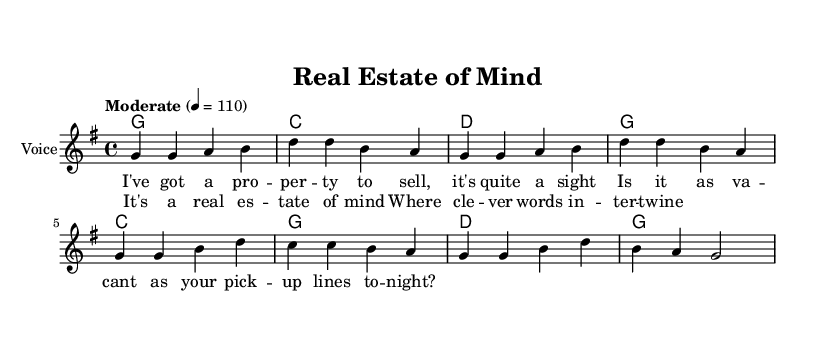What is the key signature of this music? The key signature is G major, which has one sharp (F#). This is determined by looking at the key signature indicated at the beginning of the staff.
Answer: G major What is the time signature of this piece? The time signature is 4/4, which means there are four beats in each measure and the quarter note gets one beat. This is indicated at the beginning of the music sheet.
Answer: 4/4 What is the tempo marking for the piece? The tempo marking is "Moderate", which suggests a moderate pace for the performance. This is indicated directly above the staff.
Answer: Moderate How many measures are in the verse section? The verse section contains four measures, as counted from the melody line where the verse lyrics are set. The melody indicates four distinct grouping of notes in the verse.
Answer: Four What are the last two chords in the chorus? The last two chords in the chorus are G and G. By observing the chord symbols listed in the harmony section for the chorus, we can see that it ends with these two G chords.
Answer: G G What type of lyrical content does this song feature? The song features witty wordplay, as seen in the lyrics which include clever lines that hint at the real estate theme. A close reading of the lyrics showcase puns and humorous exchanges.
Answer: Witty wordplay Which musical genre does this sheet music represent? This sheet music represents the Country Rock genre, characterized by elements of country music combined with rock influences, as seen in its structure and lyrical style.
Answer: Country Rock 